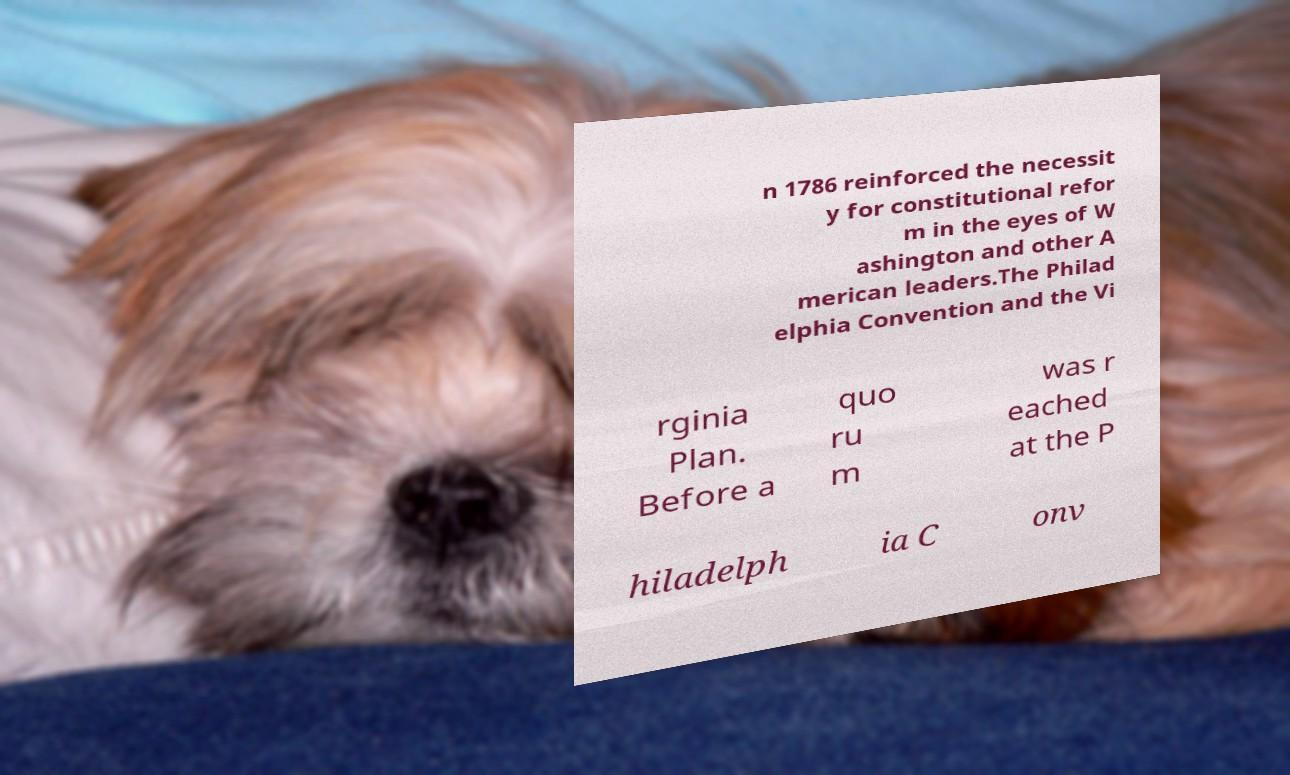Could you assist in decoding the text presented in this image and type it out clearly? n 1786 reinforced the necessit y for constitutional refor m in the eyes of W ashington and other A merican leaders.The Philad elphia Convention and the Vi rginia Plan. Before a quo ru m was r eached at the P hiladelph ia C onv 